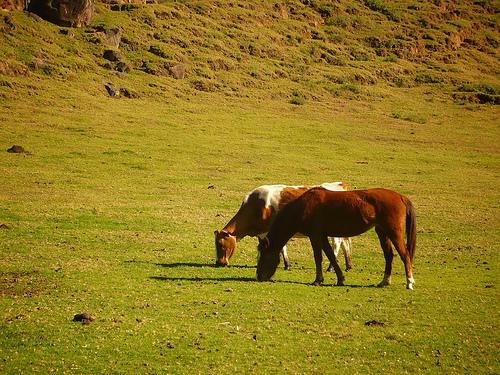Question: what is this a picture of?
Choices:
A. 2 dogs playing.
B. 2 children running.
C. A couple dancing.
D. 2 horses grazing.
Answer with the letter. Answer: D Question: why are the horses grazing?
Choices:
A. To munch.
B. To eat.
C. To maintain a healthy bodily condition.
D. To obtain energy.
Answer with the letter. Answer: B Question: where are the horses grazing?
Choices:
A. In the back yard.
B. Near the lake.
C. By the fence.
D. In an open field.
Answer with the letter. Answer: D Question: what color is the field?
Choices:
A. Black.
B. Green.
C. Red.
D. Blue.
Answer with the letter. Answer: B Question: what color are the horses?
Choices:
A. Brown and white.
B. Black.
C. Grey.
D. Red.
Answer with the letter. Answer: A Question: how many horses are in the pic?
Choices:
A. 5.
B. 6.
C. 8.
D. 2.
Answer with the letter. Answer: D 